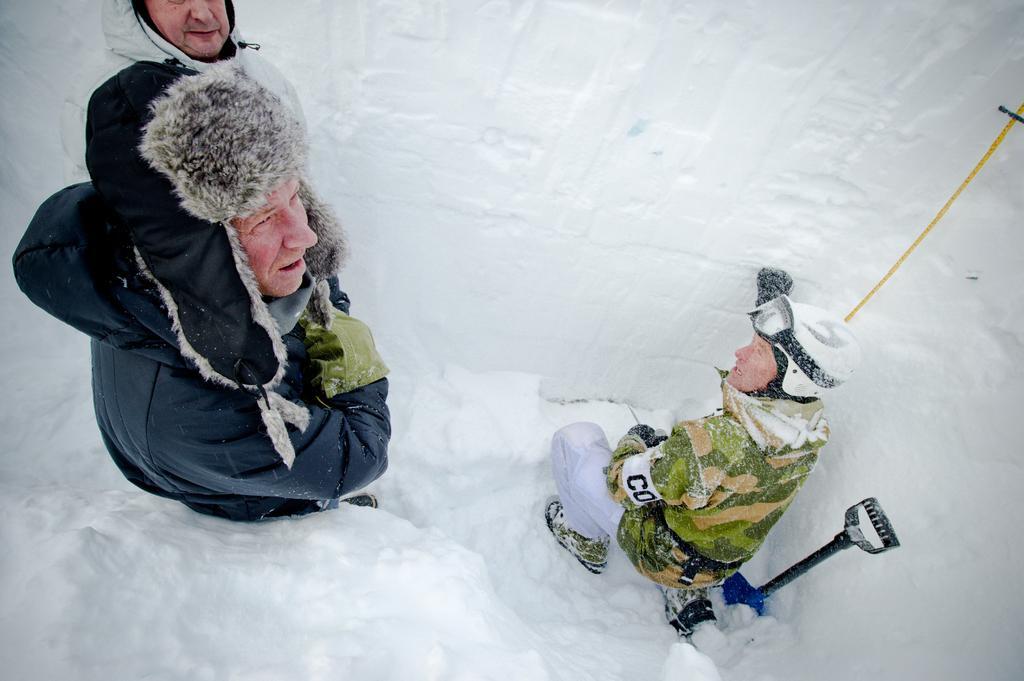Could you give a brief overview of what you see in this image? In this image in the center there are persons on the snow and there is stand on the snow. 